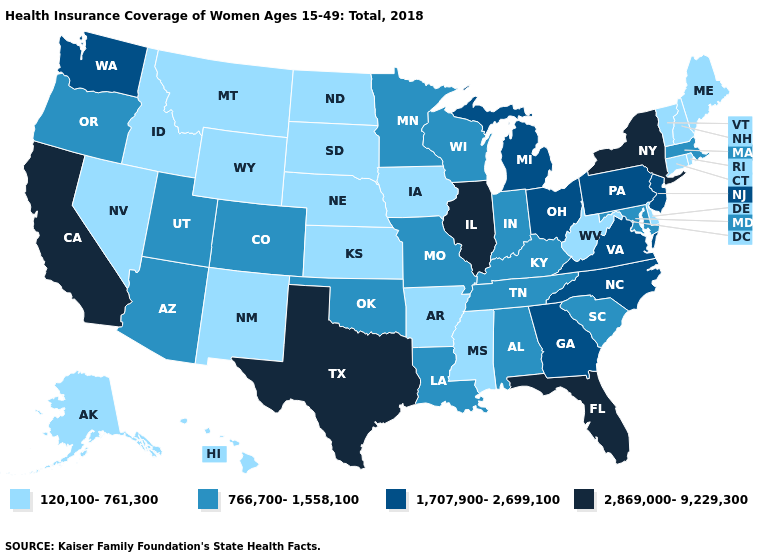Among the states that border Florida , which have the lowest value?
Concise answer only. Alabama. What is the value of Mississippi?
Concise answer only. 120,100-761,300. Among the states that border South Dakota , does Minnesota have the highest value?
Keep it brief. Yes. Does the map have missing data?
Short answer required. No. Name the states that have a value in the range 120,100-761,300?
Concise answer only. Alaska, Arkansas, Connecticut, Delaware, Hawaii, Idaho, Iowa, Kansas, Maine, Mississippi, Montana, Nebraska, Nevada, New Hampshire, New Mexico, North Dakota, Rhode Island, South Dakota, Vermont, West Virginia, Wyoming. Does Oklahoma have a lower value than Ohio?
Be succinct. Yes. What is the highest value in the USA?
Short answer required. 2,869,000-9,229,300. What is the lowest value in the USA?
Quick response, please. 120,100-761,300. Name the states that have a value in the range 120,100-761,300?
Quick response, please. Alaska, Arkansas, Connecticut, Delaware, Hawaii, Idaho, Iowa, Kansas, Maine, Mississippi, Montana, Nebraska, Nevada, New Hampshire, New Mexico, North Dakota, Rhode Island, South Dakota, Vermont, West Virginia, Wyoming. Name the states that have a value in the range 1,707,900-2,699,100?
Quick response, please. Georgia, Michigan, New Jersey, North Carolina, Ohio, Pennsylvania, Virginia, Washington. What is the highest value in states that border Georgia?
Concise answer only. 2,869,000-9,229,300. Does California have the highest value in the West?
Give a very brief answer. Yes. What is the lowest value in the USA?
Short answer required. 120,100-761,300. How many symbols are there in the legend?
Keep it brief. 4. Does the first symbol in the legend represent the smallest category?
Give a very brief answer. Yes. 